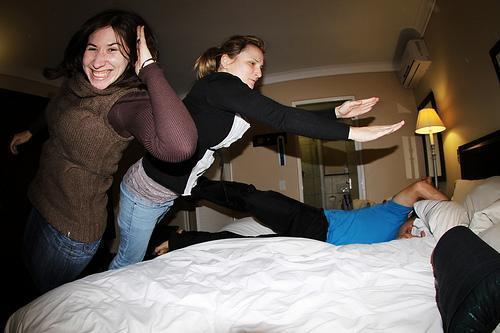How many people are already on the bed?
Give a very brief answer. 1. How many people are in this photo?
Give a very brief answer. 3. 